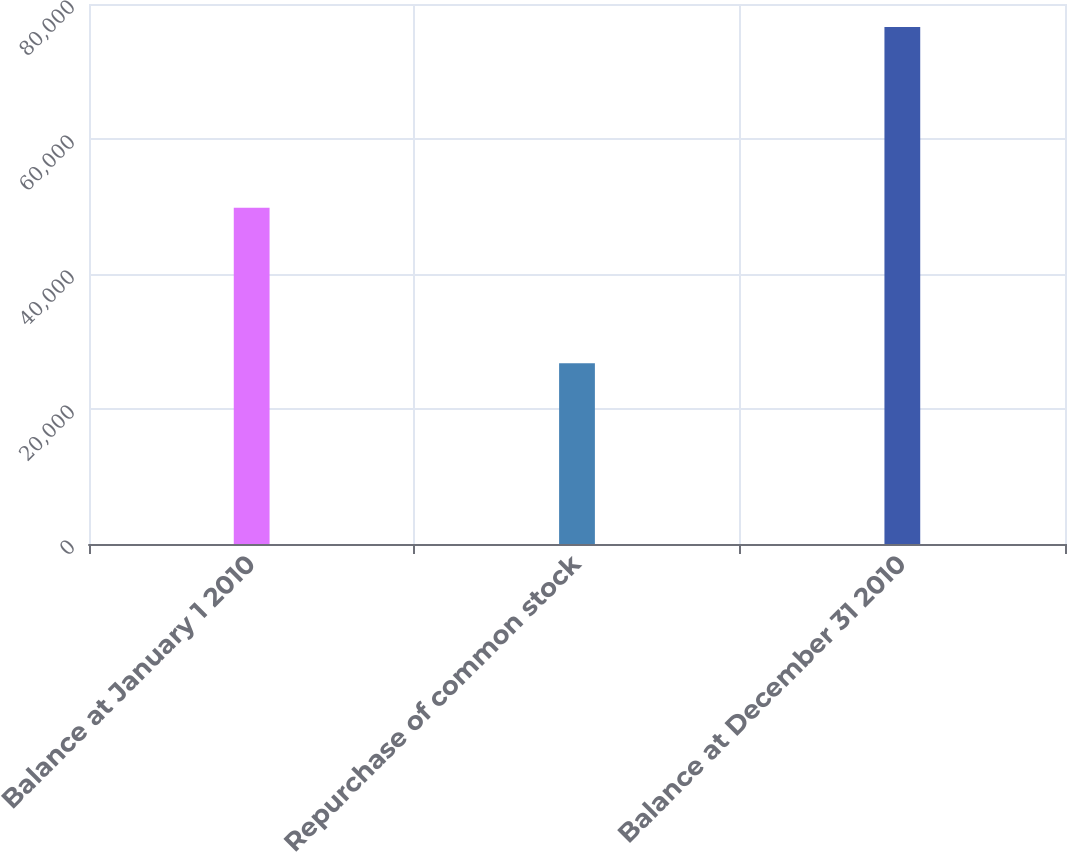Convert chart. <chart><loc_0><loc_0><loc_500><loc_500><bar_chart><fcel>Balance at January 1 2010<fcel>Repurchase of common stock<fcel>Balance at December 31 2010<nl><fcel>49805<fcel>26793<fcel>76598<nl></chart> 